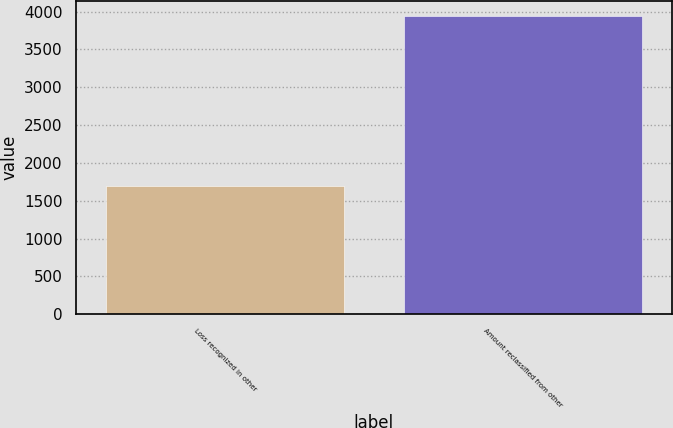<chart> <loc_0><loc_0><loc_500><loc_500><bar_chart><fcel>Loss recognized in other<fcel>Amount reclassified from other<nl><fcel>1701<fcel>3946<nl></chart> 